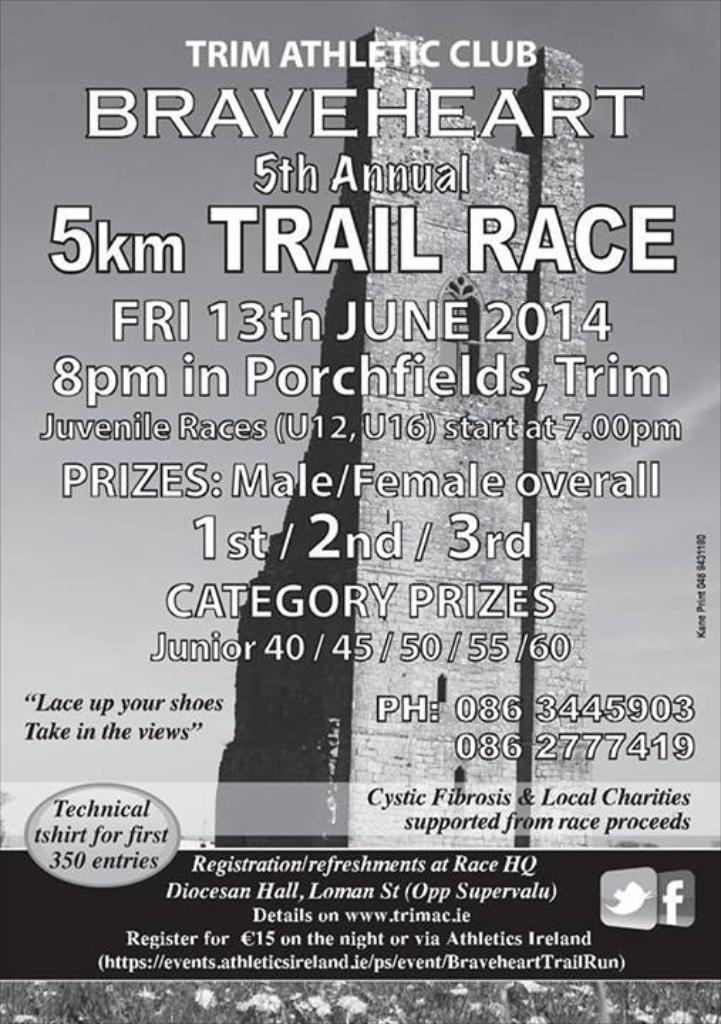How many entries get a t shirt?
Your answer should be compact. 350. 